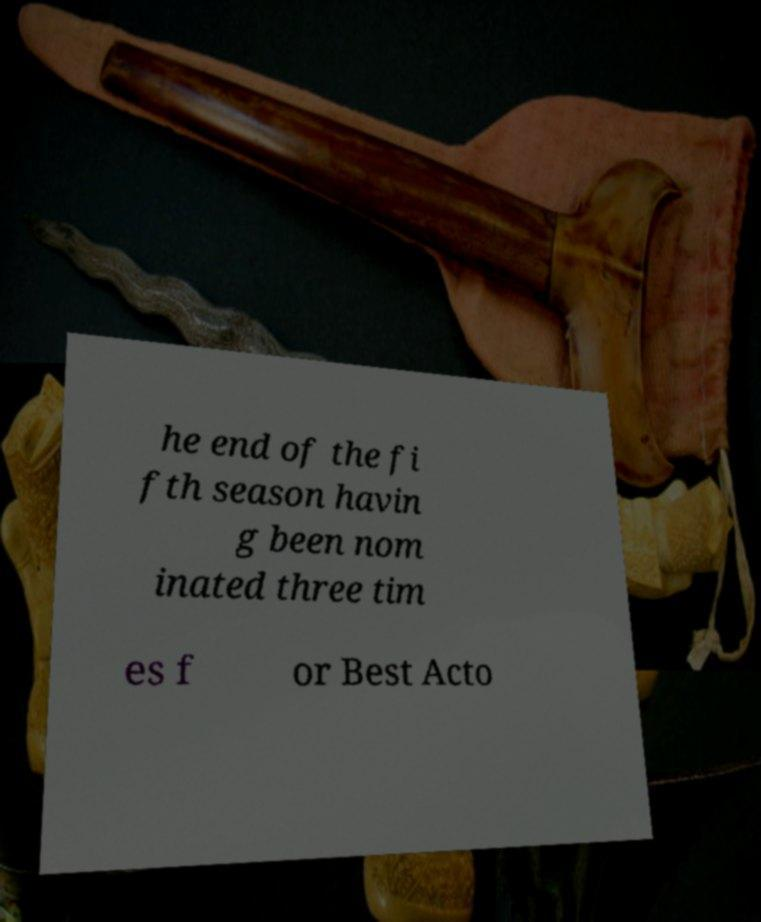Can you accurately transcribe the text from the provided image for me? he end of the fi fth season havin g been nom inated three tim es f or Best Acto 